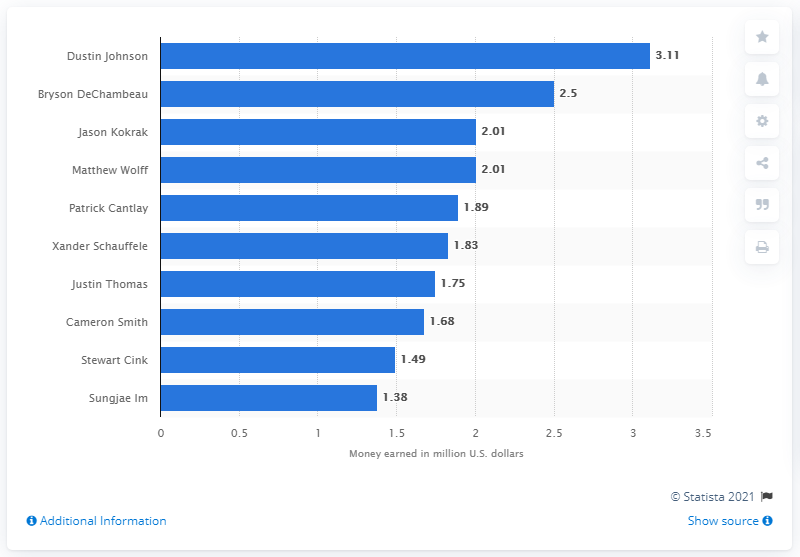Identify some key points in this picture. In the 2020 PGA Tour season, Dustin Johnson earned a significant amount of money, which can be represented as 3.11. In the 2020 PGA Tour season, Dustin Johnson was the American golfer who earned the most money. 